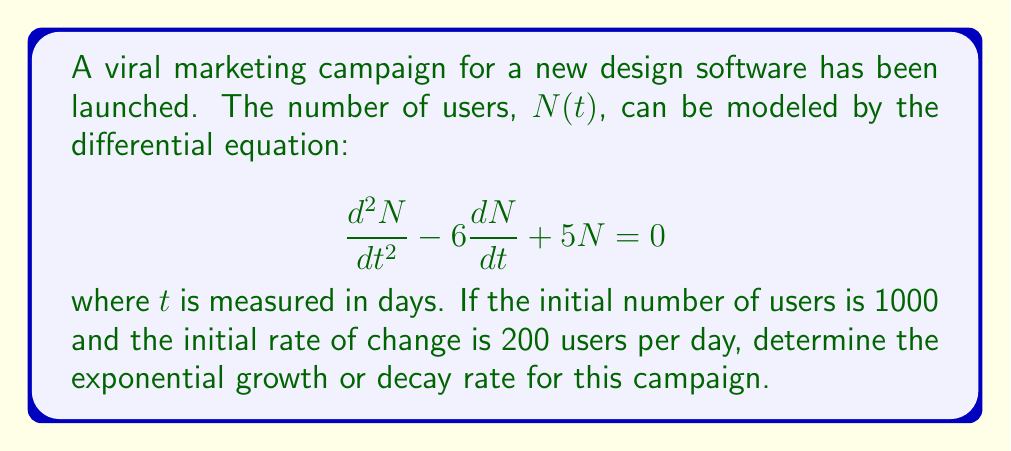Can you solve this math problem? To solve this problem, we need to follow these steps:

1) The general solution for a second-order linear differential equation of the form $\frac{d^2N}{dt^2} + a\frac{dN}{dt} + bN = 0$ is:

   $N(t) = c_1e^{r_1t} + c_2e^{r_2t}$

   where $r_1$ and $r_2$ are the roots of the characteristic equation $r^2 + ar + b = 0$.

2) In our case, the characteristic equation is:

   $r^2 - 6r + 5 = 0$

3) We can solve this using the quadratic formula:

   $r = \frac{-b \pm \sqrt{b^2 - 4ac}}{2a}$

   $r = \frac{6 \pm \sqrt{36 - 20}}{2} = \frac{6 \pm 4}{2}$

4) This gives us:

   $r_1 = 5$ and $r_2 = 1$

5) Therefore, the general solution is:

   $N(t) = c_1e^{5t} + c_2e^t$

6) To find $c_1$ and $c_2$, we use the initial conditions:

   $N(0) = 1000$ and $N'(0) = 200$

7) From $N(0) = 1000$:

   $1000 = c_1 + c_2$

8) From $N'(t) = 5c_1e^{5t} + c_2e^t$, we get $N'(0) = 200$:

   $200 = 5c_1 + c_2$

9) Solving these equations:

   $c_1 = 50$ and $c_2 = 950$

10) The final solution is:

    $N(t) = 50e^{5t} + 950e^t$

11) The exponential growth rate is determined by the larger exponent, which is 5 in this case.
Answer: The exponential growth rate for the viral marketing campaign is 5 per day. 